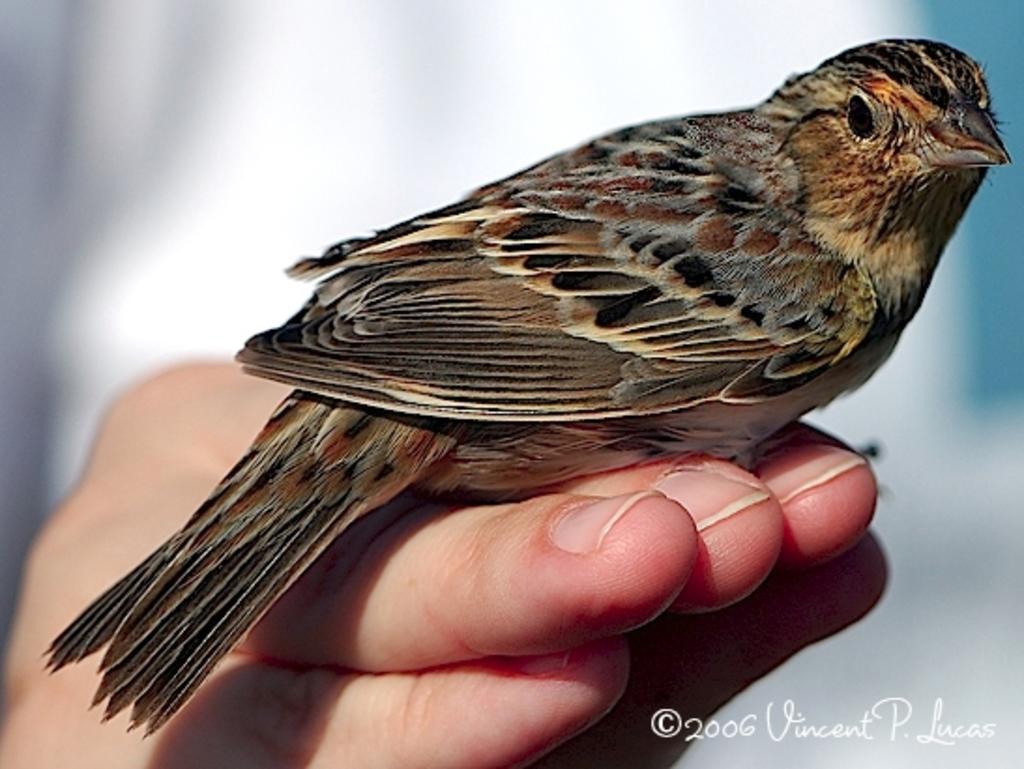Could you give a brief overview of what you see in this image? In this image there is a rose breasted grosbeak on the person hand. 